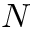<formula> <loc_0><loc_0><loc_500><loc_500>N</formula> 